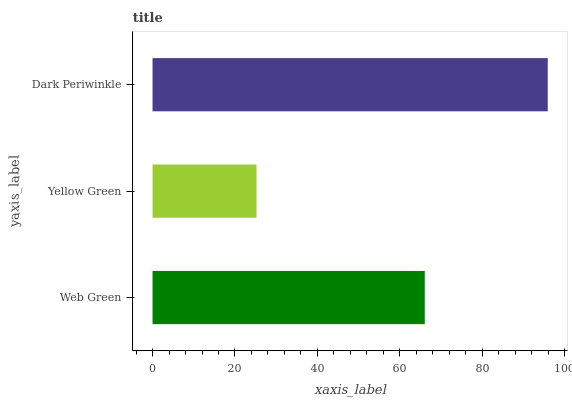Is Yellow Green the minimum?
Answer yes or no. Yes. Is Dark Periwinkle the maximum?
Answer yes or no. Yes. Is Dark Periwinkle the minimum?
Answer yes or no. No. Is Yellow Green the maximum?
Answer yes or no. No. Is Dark Periwinkle greater than Yellow Green?
Answer yes or no. Yes. Is Yellow Green less than Dark Periwinkle?
Answer yes or no. Yes. Is Yellow Green greater than Dark Periwinkle?
Answer yes or no. No. Is Dark Periwinkle less than Yellow Green?
Answer yes or no. No. Is Web Green the high median?
Answer yes or no. Yes. Is Web Green the low median?
Answer yes or no. Yes. Is Dark Periwinkle the high median?
Answer yes or no. No. Is Yellow Green the low median?
Answer yes or no. No. 